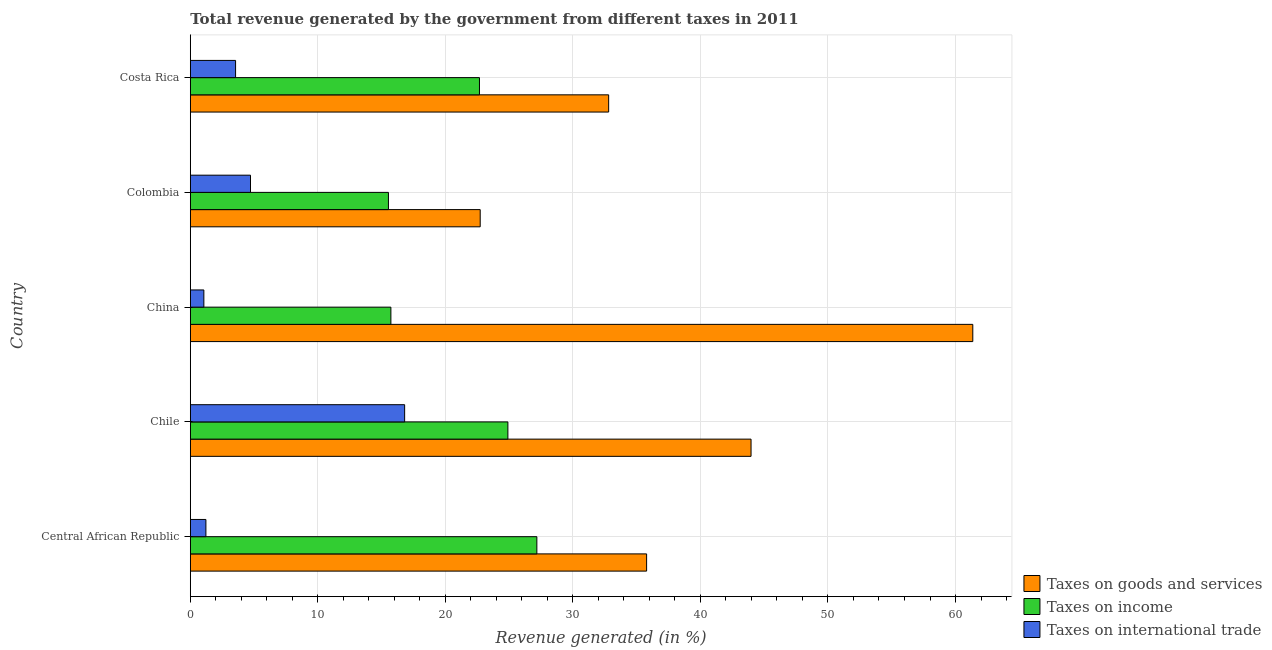How many bars are there on the 3rd tick from the top?
Give a very brief answer. 3. How many bars are there on the 1st tick from the bottom?
Give a very brief answer. 3. In how many cases, is the number of bars for a given country not equal to the number of legend labels?
Provide a short and direct response. 0. What is the percentage of revenue generated by taxes on income in Costa Rica?
Offer a terse response. 22.67. Across all countries, what is the maximum percentage of revenue generated by taxes on income?
Your response must be concise. 27.17. Across all countries, what is the minimum percentage of revenue generated by tax on international trade?
Your answer should be compact. 1.06. What is the total percentage of revenue generated by taxes on goods and services in the graph?
Give a very brief answer. 196.64. What is the difference between the percentage of revenue generated by taxes on income in China and that in Costa Rica?
Your answer should be very brief. -6.95. What is the difference between the percentage of revenue generated by tax on international trade in Colombia and the percentage of revenue generated by taxes on income in China?
Provide a succinct answer. -11.01. What is the average percentage of revenue generated by taxes on income per country?
Your response must be concise. 21.2. What is the difference between the percentage of revenue generated by taxes on goods and services and percentage of revenue generated by tax on international trade in Costa Rica?
Make the answer very short. 29.25. What is the ratio of the percentage of revenue generated by taxes on income in Central African Republic to that in Costa Rica?
Give a very brief answer. 1.2. Is the percentage of revenue generated by taxes on income in Chile less than that in China?
Give a very brief answer. No. What is the difference between the highest and the second highest percentage of revenue generated by taxes on income?
Provide a short and direct response. 2.27. What is the difference between the highest and the lowest percentage of revenue generated by taxes on income?
Ensure brevity in your answer.  11.64. What does the 2nd bar from the top in Central African Republic represents?
Keep it short and to the point. Taxes on income. What does the 1st bar from the bottom in Chile represents?
Ensure brevity in your answer.  Taxes on goods and services. Is it the case that in every country, the sum of the percentage of revenue generated by taxes on goods and services and percentage of revenue generated by taxes on income is greater than the percentage of revenue generated by tax on international trade?
Your answer should be very brief. Yes. Are all the bars in the graph horizontal?
Give a very brief answer. Yes. Does the graph contain grids?
Provide a succinct answer. Yes. Where does the legend appear in the graph?
Your answer should be compact. Bottom right. How are the legend labels stacked?
Your answer should be very brief. Vertical. What is the title of the graph?
Your answer should be very brief. Total revenue generated by the government from different taxes in 2011. Does "Agricultural raw materials" appear as one of the legend labels in the graph?
Keep it short and to the point. No. What is the label or title of the X-axis?
Provide a succinct answer. Revenue generated (in %). What is the Revenue generated (in %) in Taxes on goods and services in Central African Republic?
Make the answer very short. 35.78. What is the Revenue generated (in %) of Taxes on income in Central African Republic?
Offer a terse response. 27.17. What is the Revenue generated (in %) in Taxes on international trade in Central African Republic?
Make the answer very short. 1.22. What is the Revenue generated (in %) of Taxes on goods and services in Chile?
Your answer should be very brief. 43.97. What is the Revenue generated (in %) of Taxes on income in Chile?
Give a very brief answer. 24.9. What is the Revenue generated (in %) in Taxes on international trade in Chile?
Your answer should be very brief. 16.81. What is the Revenue generated (in %) of Taxes on goods and services in China?
Keep it short and to the point. 61.36. What is the Revenue generated (in %) in Taxes on income in China?
Your answer should be compact. 15.73. What is the Revenue generated (in %) in Taxes on international trade in China?
Keep it short and to the point. 1.06. What is the Revenue generated (in %) of Taxes on goods and services in Colombia?
Give a very brief answer. 22.73. What is the Revenue generated (in %) of Taxes on income in Colombia?
Ensure brevity in your answer.  15.54. What is the Revenue generated (in %) in Taxes on international trade in Colombia?
Your answer should be very brief. 4.72. What is the Revenue generated (in %) of Taxes on goods and services in Costa Rica?
Offer a terse response. 32.8. What is the Revenue generated (in %) in Taxes on income in Costa Rica?
Your response must be concise. 22.67. What is the Revenue generated (in %) of Taxes on international trade in Costa Rica?
Provide a succinct answer. 3.55. Across all countries, what is the maximum Revenue generated (in %) of Taxes on goods and services?
Provide a succinct answer. 61.36. Across all countries, what is the maximum Revenue generated (in %) in Taxes on income?
Keep it short and to the point. 27.17. Across all countries, what is the maximum Revenue generated (in %) in Taxes on international trade?
Your answer should be very brief. 16.81. Across all countries, what is the minimum Revenue generated (in %) in Taxes on goods and services?
Give a very brief answer. 22.73. Across all countries, what is the minimum Revenue generated (in %) of Taxes on income?
Your answer should be compact. 15.54. Across all countries, what is the minimum Revenue generated (in %) in Taxes on international trade?
Provide a succinct answer. 1.06. What is the total Revenue generated (in %) in Taxes on goods and services in the graph?
Your response must be concise. 196.64. What is the total Revenue generated (in %) in Taxes on income in the graph?
Provide a short and direct response. 106.01. What is the total Revenue generated (in %) of Taxes on international trade in the graph?
Offer a very short reply. 27.37. What is the difference between the Revenue generated (in %) in Taxes on goods and services in Central African Republic and that in Chile?
Make the answer very short. -8.19. What is the difference between the Revenue generated (in %) in Taxes on income in Central African Republic and that in Chile?
Ensure brevity in your answer.  2.27. What is the difference between the Revenue generated (in %) in Taxes on international trade in Central African Republic and that in Chile?
Offer a very short reply. -15.58. What is the difference between the Revenue generated (in %) of Taxes on goods and services in Central African Republic and that in China?
Make the answer very short. -25.58. What is the difference between the Revenue generated (in %) of Taxes on income in Central African Republic and that in China?
Keep it short and to the point. 11.45. What is the difference between the Revenue generated (in %) in Taxes on international trade in Central African Republic and that in China?
Provide a succinct answer. 0.16. What is the difference between the Revenue generated (in %) of Taxes on goods and services in Central African Republic and that in Colombia?
Ensure brevity in your answer.  13.05. What is the difference between the Revenue generated (in %) of Taxes on income in Central African Republic and that in Colombia?
Your answer should be very brief. 11.64. What is the difference between the Revenue generated (in %) in Taxes on international trade in Central African Republic and that in Colombia?
Make the answer very short. -3.5. What is the difference between the Revenue generated (in %) of Taxes on goods and services in Central African Republic and that in Costa Rica?
Your response must be concise. 2.98. What is the difference between the Revenue generated (in %) in Taxes on income in Central African Republic and that in Costa Rica?
Your answer should be very brief. 4.5. What is the difference between the Revenue generated (in %) in Taxes on international trade in Central African Republic and that in Costa Rica?
Provide a succinct answer. -2.33. What is the difference between the Revenue generated (in %) of Taxes on goods and services in Chile and that in China?
Make the answer very short. -17.39. What is the difference between the Revenue generated (in %) of Taxes on income in Chile and that in China?
Ensure brevity in your answer.  9.17. What is the difference between the Revenue generated (in %) in Taxes on international trade in Chile and that in China?
Keep it short and to the point. 15.74. What is the difference between the Revenue generated (in %) of Taxes on goods and services in Chile and that in Colombia?
Offer a very short reply. 21.24. What is the difference between the Revenue generated (in %) in Taxes on income in Chile and that in Colombia?
Provide a short and direct response. 9.37. What is the difference between the Revenue generated (in %) in Taxes on international trade in Chile and that in Colombia?
Offer a very short reply. 12.09. What is the difference between the Revenue generated (in %) of Taxes on goods and services in Chile and that in Costa Rica?
Offer a very short reply. 11.16. What is the difference between the Revenue generated (in %) in Taxes on income in Chile and that in Costa Rica?
Your answer should be compact. 2.23. What is the difference between the Revenue generated (in %) in Taxes on international trade in Chile and that in Costa Rica?
Keep it short and to the point. 13.26. What is the difference between the Revenue generated (in %) in Taxes on goods and services in China and that in Colombia?
Provide a short and direct response. 38.62. What is the difference between the Revenue generated (in %) of Taxes on income in China and that in Colombia?
Give a very brief answer. 0.19. What is the difference between the Revenue generated (in %) in Taxes on international trade in China and that in Colombia?
Your response must be concise. -3.66. What is the difference between the Revenue generated (in %) in Taxes on goods and services in China and that in Costa Rica?
Your response must be concise. 28.55. What is the difference between the Revenue generated (in %) in Taxes on income in China and that in Costa Rica?
Keep it short and to the point. -6.95. What is the difference between the Revenue generated (in %) of Taxes on international trade in China and that in Costa Rica?
Your answer should be compact. -2.49. What is the difference between the Revenue generated (in %) of Taxes on goods and services in Colombia and that in Costa Rica?
Provide a succinct answer. -10.07. What is the difference between the Revenue generated (in %) of Taxes on income in Colombia and that in Costa Rica?
Your answer should be compact. -7.14. What is the difference between the Revenue generated (in %) of Taxes on international trade in Colombia and that in Costa Rica?
Offer a terse response. 1.17. What is the difference between the Revenue generated (in %) in Taxes on goods and services in Central African Republic and the Revenue generated (in %) in Taxes on income in Chile?
Give a very brief answer. 10.88. What is the difference between the Revenue generated (in %) of Taxes on goods and services in Central African Republic and the Revenue generated (in %) of Taxes on international trade in Chile?
Offer a very short reply. 18.97. What is the difference between the Revenue generated (in %) in Taxes on income in Central African Republic and the Revenue generated (in %) in Taxes on international trade in Chile?
Your answer should be very brief. 10.37. What is the difference between the Revenue generated (in %) in Taxes on goods and services in Central African Republic and the Revenue generated (in %) in Taxes on income in China?
Ensure brevity in your answer.  20.05. What is the difference between the Revenue generated (in %) of Taxes on goods and services in Central African Republic and the Revenue generated (in %) of Taxes on international trade in China?
Your answer should be very brief. 34.72. What is the difference between the Revenue generated (in %) of Taxes on income in Central African Republic and the Revenue generated (in %) of Taxes on international trade in China?
Your response must be concise. 26.11. What is the difference between the Revenue generated (in %) of Taxes on goods and services in Central African Republic and the Revenue generated (in %) of Taxes on income in Colombia?
Offer a very short reply. 20.24. What is the difference between the Revenue generated (in %) of Taxes on goods and services in Central African Republic and the Revenue generated (in %) of Taxes on international trade in Colombia?
Your response must be concise. 31.06. What is the difference between the Revenue generated (in %) in Taxes on income in Central African Republic and the Revenue generated (in %) in Taxes on international trade in Colombia?
Your answer should be very brief. 22.45. What is the difference between the Revenue generated (in %) of Taxes on goods and services in Central African Republic and the Revenue generated (in %) of Taxes on income in Costa Rica?
Your response must be concise. 13.11. What is the difference between the Revenue generated (in %) in Taxes on goods and services in Central African Republic and the Revenue generated (in %) in Taxes on international trade in Costa Rica?
Your answer should be compact. 32.23. What is the difference between the Revenue generated (in %) of Taxes on income in Central African Republic and the Revenue generated (in %) of Taxes on international trade in Costa Rica?
Offer a terse response. 23.62. What is the difference between the Revenue generated (in %) in Taxes on goods and services in Chile and the Revenue generated (in %) in Taxes on income in China?
Provide a short and direct response. 28.24. What is the difference between the Revenue generated (in %) of Taxes on goods and services in Chile and the Revenue generated (in %) of Taxes on international trade in China?
Give a very brief answer. 42.91. What is the difference between the Revenue generated (in %) of Taxes on income in Chile and the Revenue generated (in %) of Taxes on international trade in China?
Offer a very short reply. 23.84. What is the difference between the Revenue generated (in %) of Taxes on goods and services in Chile and the Revenue generated (in %) of Taxes on income in Colombia?
Ensure brevity in your answer.  28.43. What is the difference between the Revenue generated (in %) of Taxes on goods and services in Chile and the Revenue generated (in %) of Taxes on international trade in Colombia?
Offer a terse response. 39.25. What is the difference between the Revenue generated (in %) of Taxes on income in Chile and the Revenue generated (in %) of Taxes on international trade in Colombia?
Your response must be concise. 20.18. What is the difference between the Revenue generated (in %) in Taxes on goods and services in Chile and the Revenue generated (in %) in Taxes on income in Costa Rica?
Provide a succinct answer. 21.3. What is the difference between the Revenue generated (in %) of Taxes on goods and services in Chile and the Revenue generated (in %) of Taxes on international trade in Costa Rica?
Provide a succinct answer. 40.42. What is the difference between the Revenue generated (in %) in Taxes on income in Chile and the Revenue generated (in %) in Taxes on international trade in Costa Rica?
Keep it short and to the point. 21.35. What is the difference between the Revenue generated (in %) in Taxes on goods and services in China and the Revenue generated (in %) in Taxes on income in Colombia?
Your answer should be compact. 45.82. What is the difference between the Revenue generated (in %) in Taxes on goods and services in China and the Revenue generated (in %) in Taxes on international trade in Colombia?
Your answer should be very brief. 56.64. What is the difference between the Revenue generated (in %) in Taxes on income in China and the Revenue generated (in %) in Taxes on international trade in Colombia?
Make the answer very short. 11.01. What is the difference between the Revenue generated (in %) in Taxes on goods and services in China and the Revenue generated (in %) in Taxes on income in Costa Rica?
Offer a terse response. 38.68. What is the difference between the Revenue generated (in %) of Taxes on goods and services in China and the Revenue generated (in %) of Taxes on international trade in Costa Rica?
Give a very brief answer. 57.81. What is the difference between the Revenue generated (in %) of Taxes on income in China and the Revenue generated (in %) of Taxes on international trade in Costa Rica?
Offer a terse response. 12.18. What is the difference between the Revenue generated (in %) of Taxes on goods and services in Colombia and the Revenue generated (in %) of Taxes on income in Costa Rica?
Ensure brevity in your answer.  0.06. What is the difference between the Revenue generated (in %) in Taxes on goods and services in Colombia and the Revenue generated (in %) in Taxes on international trade in Costa Rica?
Make the answer very short. 19.18. What is the difference between the Revenue generated (in %) in Taxes on income in Colombia and the Revenue generated (in %) in Taxes on international trade in Costa Rica?
Provide a succinct answer. 11.99. What is the average Revenue generated (in %) of Taxes on goods and services per country?
Give a very brief answer. 39.33. What is the average Revenue generated (in %) in Taxes on income per country?
Provide a short and direct response. 21.2. What is the average Revenue generated (in %) in Taxes on international trade per country?
Make the answer very short. 5.47. What is the difference between the Revenue generated (in %) in Taxes on goods and services and Revenue generated (in %) in Taxes on income in Central African Republic?
Ensure brevity in your answer.  8.6. What is the difference between the Revenue generated (in %) in Taxes on goods and services and Revenue generated (in %) in Taxes on international trade in Central African Republic?
Give a very brief answer. 34.55. What is the difference between the Revenue generated (in %) of Taxes on income and Revenue generated (in %) of Taxes on international trade in Central African Republic?
Give a very brief answer. 25.95. What is the difference between the Revenue generated (in %) in Taxes on goods and services and Revenue generated (in %) in Taxes on income in Chile?
Offer a terse response. 19.07. What is the difference between the Revenue generated (in %) in Taxes on goods and services and Revenue generated (in %) in Taxes on international trade in Chile?
Provide a succinct answer. 27.16. What is the difference between the Revenue generated (in %) in Taxes on income and Revenue generated (in %) in Taxes on international trade in Chile?
Your response must be concise. 8.1. What is the difference between the Revenue generated (in %) of Taxes on goods and services and Revenue generated (in %) of Taxes on income in China?
Keep it short and to the point. 45.63. What is the difference between the Revenue generated (in %) of Taxes on goods and services and Revenue generated (in %) of Taxes on international trade in China?
Ensure brevity in your answer.  60.29. What is the difference between the Revenue generated (in %) in Taxes on income and Revenue generated (in %) in Taxes on international trade in China?
Offer a terse response. 14.66. What is the difference between the Revenue generated (in %) of Taxes on goods and services and Revenue generated (in %) of Taxes on income in Colombia?
Give a very brief answer. 7.2. What is the difference between the Revenue generated (in %) of Taxes on goods and services and Revenue generated (in %) of Taxes on international trade in Colombia?
Offer a terse response. 18.01. What is the difference between the Revenue generated (in %) of Taxes on income and Revenue generated (in %) of Taxes on international trade in Colombia?
Give a very brief answer. 10.81. What is the difference between the Revenue generated (in %) of Taxes on goods and services and Revenue generated (in %) of Taxes on income in Costa Rica?
Give a very brief answer. 10.13. What is the difference between the Revenue generated (in %) of Taxes on goods and services and Revenue generated (in %) of Taxes on international trade in Costa Rica?
Your response must be concise. 29.25. What is the difference between the Revenue generated (in %) of Taxes on income and Revenue generated (in %) of Taxes on international trade in Costa Rica?
Offer a very short reply. 19.12. What is the ratio of the Revenue generated (in %) in Taxes on goods and services in Central African Republic to that in Chile?
Provide a short and direct response. 0.81. What is the ratio of the Revenue generated (in %) in Taxes on income in Central African Republic to that in Chile?
Offer a terse response. 1.09. What is the ratio of the Revenue generated (in %) of Taxes on international trade in Central African Republic to that in Chile?
Offer a very short reply. 0.07. What is the ratio of the Revenue generated (in %) in Taxes on goods and services in Central African Republic to that in China?
Provide a succinct answer. 0.58. What is the ratio of the Revenue generated (in %) in Taxes on income in Central African Republic to that in China?
Your answer should be compact. 1.73. What is the ratio of the Revenue generated (in %) of Taxes on international trade in Central African Republic to that in China?
Ensure brevity in your answer.  1.15. What is the ratio of the Revenue generated (in %) in Taxes on goods and services in Central African Republic to that in Colombia?
Your answer should be compact. 1.57. What is the ratio of the Revenue generated (in %) in Taxes on income in Central African Republic to that in Colombia?
Your answer should be compact. 1.75. What is the ratio of the Revenue generated (in %) of Taxes on international trade in Central African Republic to that in Colombia?
Give a very brief answer. 0.26. What is the ratio of the Revenue generated (in %) of Taxes on goods and services in Central African Republic to that in Costa Rica?
Provide a short and direct response. 1.09. What is the ratio of the Revenue generated (in %) in Taxes on income in Central African Republic to that in Costa Rica?
Provide a succinct answer. 1.2. What is the ratio of the Revenue generated (in %) of Taxes on international trade in Central African Republic to that in Costa Rica?
Keep it short and to the point. 0.34. What is the ratio of the Revenue generated (in %) of Taxes on goods and services in Chile to that in China?
Your response must be concise. 0.72. What is the ratio of the Revenue generated (in %) in Taxes on income in Chile to that in China?
Your answer should be very brief. 1.58. What is the ratio of the Revenue generated (in %) of Taxes on international trade in Chile to that in China?
Your answer should be very brief. 15.8. What is the ratio of the Revenue generated (in %) in Taxes on goods and services in Chile to that in Colombia?
Your response must be concise. 1.93. What is the ratio of the Revenue generated (in %) in Taxes on income in Chile to that in Colombia?
Ensure brevity in your answer.  1.6. What is the ratio of the Revenue generated (in %) in Taxes on international trade in Chile to that in Colombia?
Provide a short and direct response. 3.56. What is the ratio of the Revenue generated (in %) in Taxes on goods and services in Chile to that in Costa Rica?
Make the answer very short. 1.34. What is the ratio of the Revenue generated (in %) in Taxes on income in Chile to that in Costa Rica?
Make the answer very short. 1.1. What is the ratio of the Revenue generated (in %) in Taxes on international trade in Chile to that in Costa Rica?
Make the answer very short. 4.73. What is the ratio of the Revenue generated (in %) in Taxes on goods and services in China to that in Colombia?
Make the answer very short. 2.7. What is the ratio of the Revenue generated (in %) in Taxes on income in China to that in Colombia?
Make the answer very short. 1.01. What is the ratio of the Revenue generated (in %) in Taxes on international trade in China to that in Colombia?
Offer a terse response. 0.23. What is the ratio of the Revenue generated (in %) of Taxes on goods and services in China to that in Costa Rica?
Your response must be concise. 1.87. What is the ratio of the Revenue generated (in %) in Taxes on income in China to that in Costa Rica?
Provide a succinct answer. 0.69. What is the ratio of the Revenue generated (in %) of Taxes on international trade in China to that in Costa Rica?
Keep it short and to the point. 0.3. What is the ratio of the Revenue generated (in %) in Taxes on goods and services in Colombia to that in Costa Rica?
Keep it short and to the point. 0.69. What is the ratio of the Revenue generated (in %) in Taxes on income in Colombia to that in Costa Rica?
Offer a terse response. 0.69. What is the ratio of the Revenue generated (in %) of Taxes on international trade in Colombia to that in Costa Rica?
Ensure brevity in your answer.  1.33. What is the difference between the highest and the second highest Revenue generated (in %) of Taxes on goods and services?
Your answer should be very brief. 17.39. What is the difference between the highest and the second highest Revenue generated (in %) in Taxes on income?
Your answer should be very brief. 2.27. What is the difference between the highest and the second highest Revenue generated (in %) in Taxes on international trade?
Give a very brief answer. 12.09. What is the difference between the highest and the lowest Revenue generated (in %) of Taxes on goods and services?
Provide a succinct answer. 38.62. What is the difference between the highest and the lowest Revenue generated (in %) of Taxes on income?
Offer a terse response. 11.64. What is the difference between the highest and the lowest Revenue generated (in %) of Taxes on international trade?
Give a very brief answer. 15.74. 